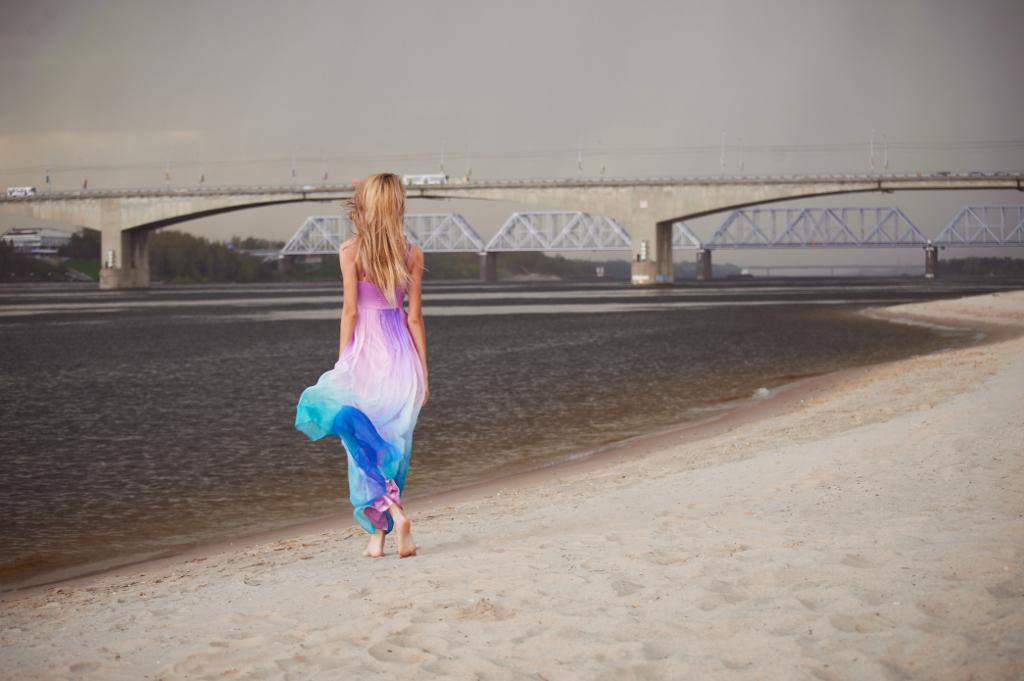Describe this image in one or two sentences. This picture is clicked outside. On the left we can see a person wearing frock and walking on the mud and we can see a water body, bridge, metal rods, trees, sky and some other objects. 